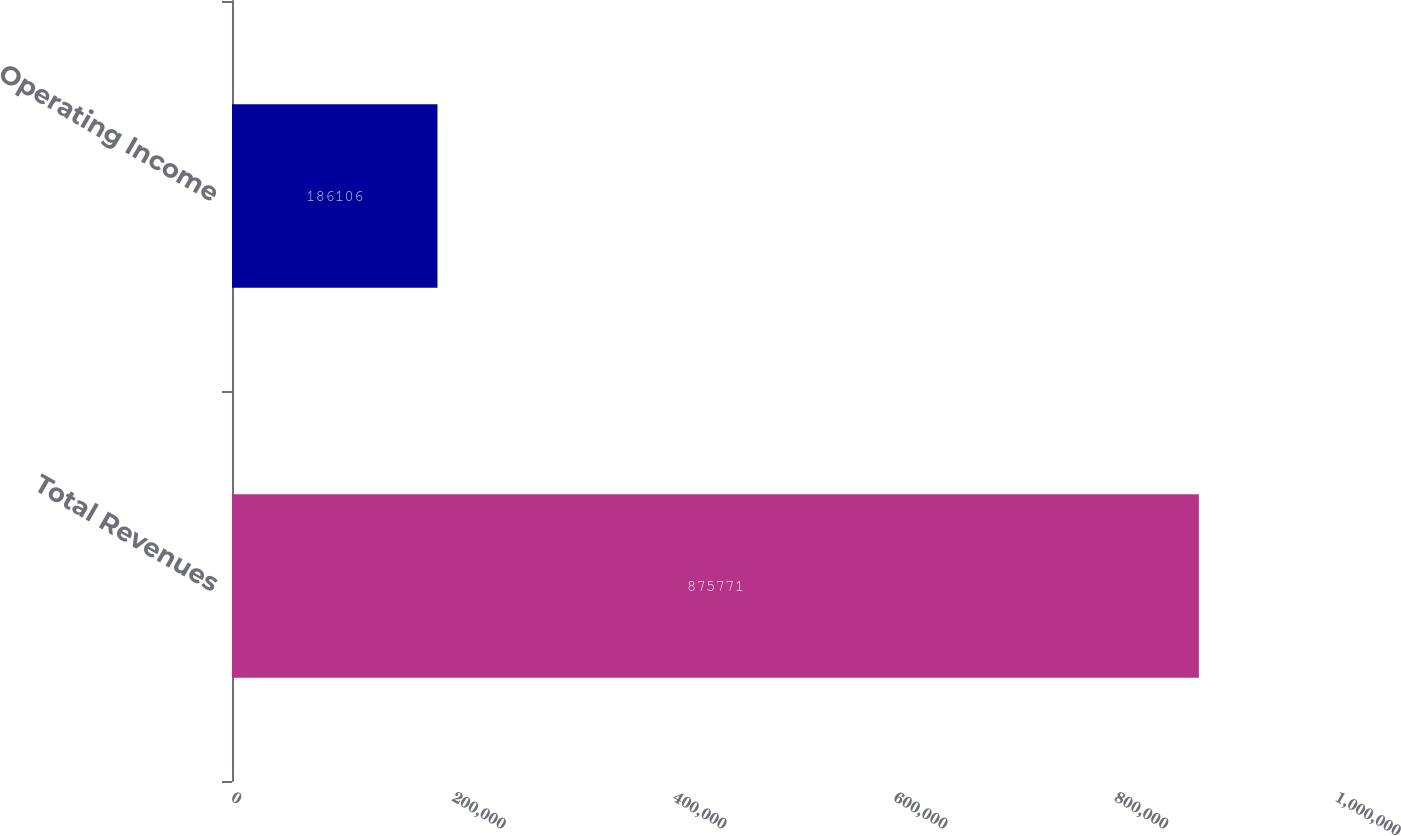Convert chart to OTSL. <chart><loc_0><loc_0><loc_500><loc_500><bar_chart><fcel>Total Revenues<fcel>Operating Income<nl><fcel>875771<fcel>186106<nl></chart> 